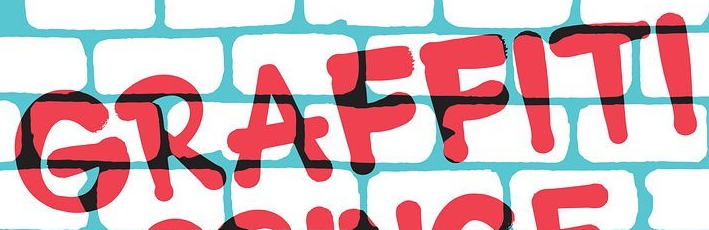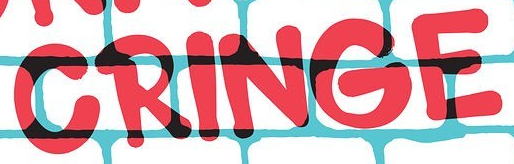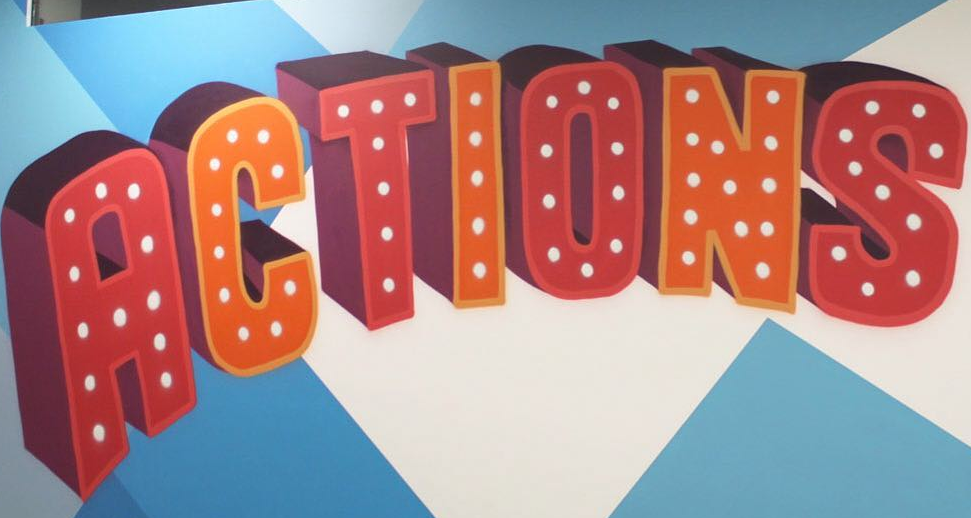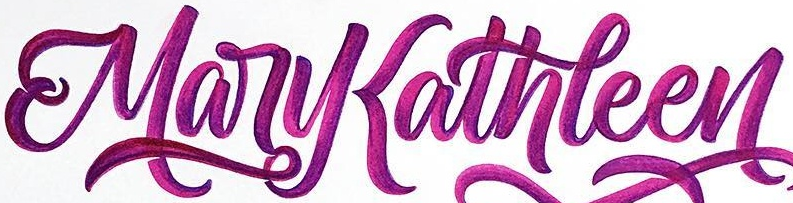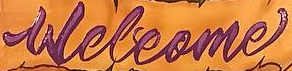Read the text from these images in sequence, separated by a semicolon. GRAFFITI; CRINGE; ACTIONS; MaryKathleen; Welcome 